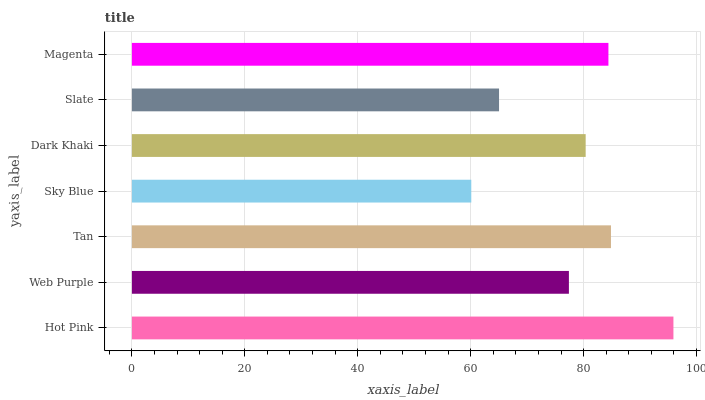Is Sky Blue the minimum?
Answer yes or no. Yes. Is Hot Pink the maximum?
Answer yes or no. Yes. Is Web Purple the minimum?
Answer yes or no. No. Is Web Purple the maximum?
Answer yes or no. No. Is Hot Pink greater than Web Purple?
Answer yes or no. Yes. Is Web Purple less than Hot Pink?
Answer yes or no. Yes. Is Web Purple greater than Hot Pink?
Answer yes or no. No. Is Hot Pink less than Web Purple?
Answer yes or no. No. Is Dark Khaki the high median?
Answer yes or no. Yes. Is Dark Khaki the low median?
Answer yes or no. Yes. Is Sky Blue the high median?
Answer yes or no. No. Is Tan the low median?
Answer yes or no. No. 